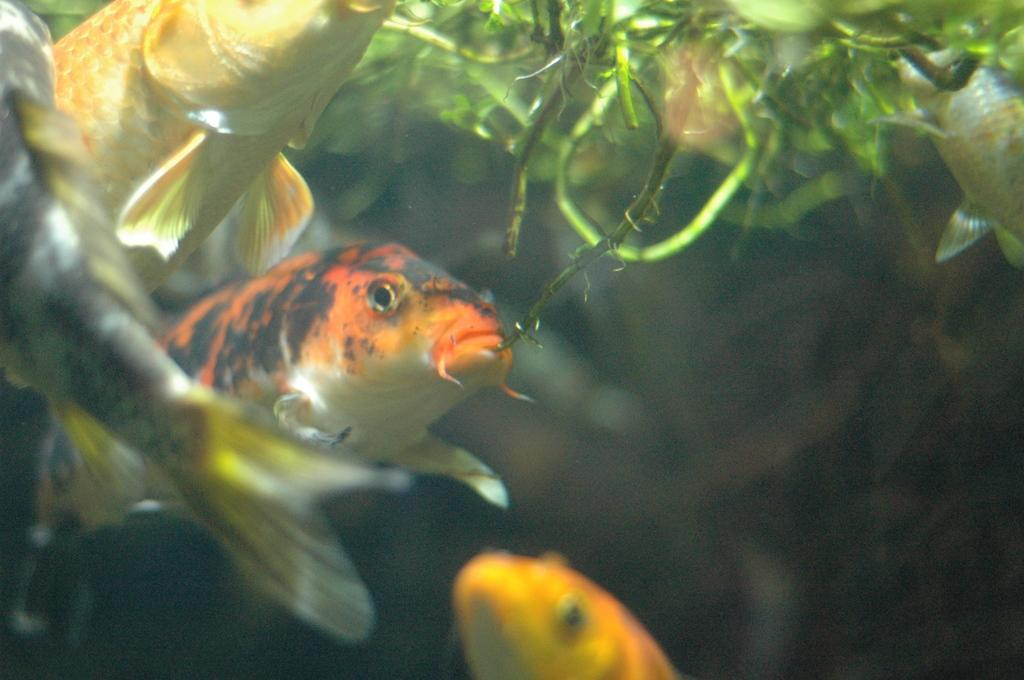What type of animals can be seen in the water in the image? There are fishes in the water in the image. What else can be seen in the water besides the fishes? There are plants in the water. How many men can be seen in the image? There are no men present in the image; it features fishes and plants in the water. What type of skin is visible on the fishes in the image? There is no specific skin type mentioned for the fishes in the image, and it is not possible to determine the skin type from the image alone. 